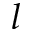<formula> <loc_0><loc_0><loc_500><loc_500>l</formula> 